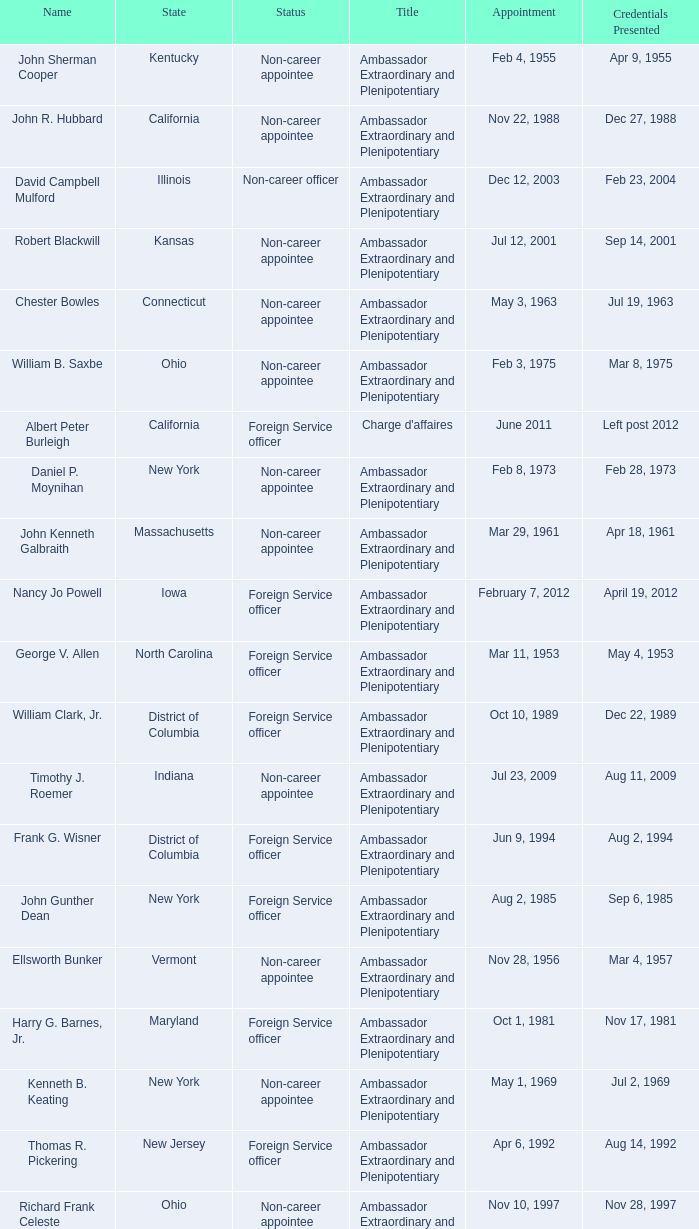When were the credentials presented for new jersey with a status of foreign service officer? Aug 14, 1992. 